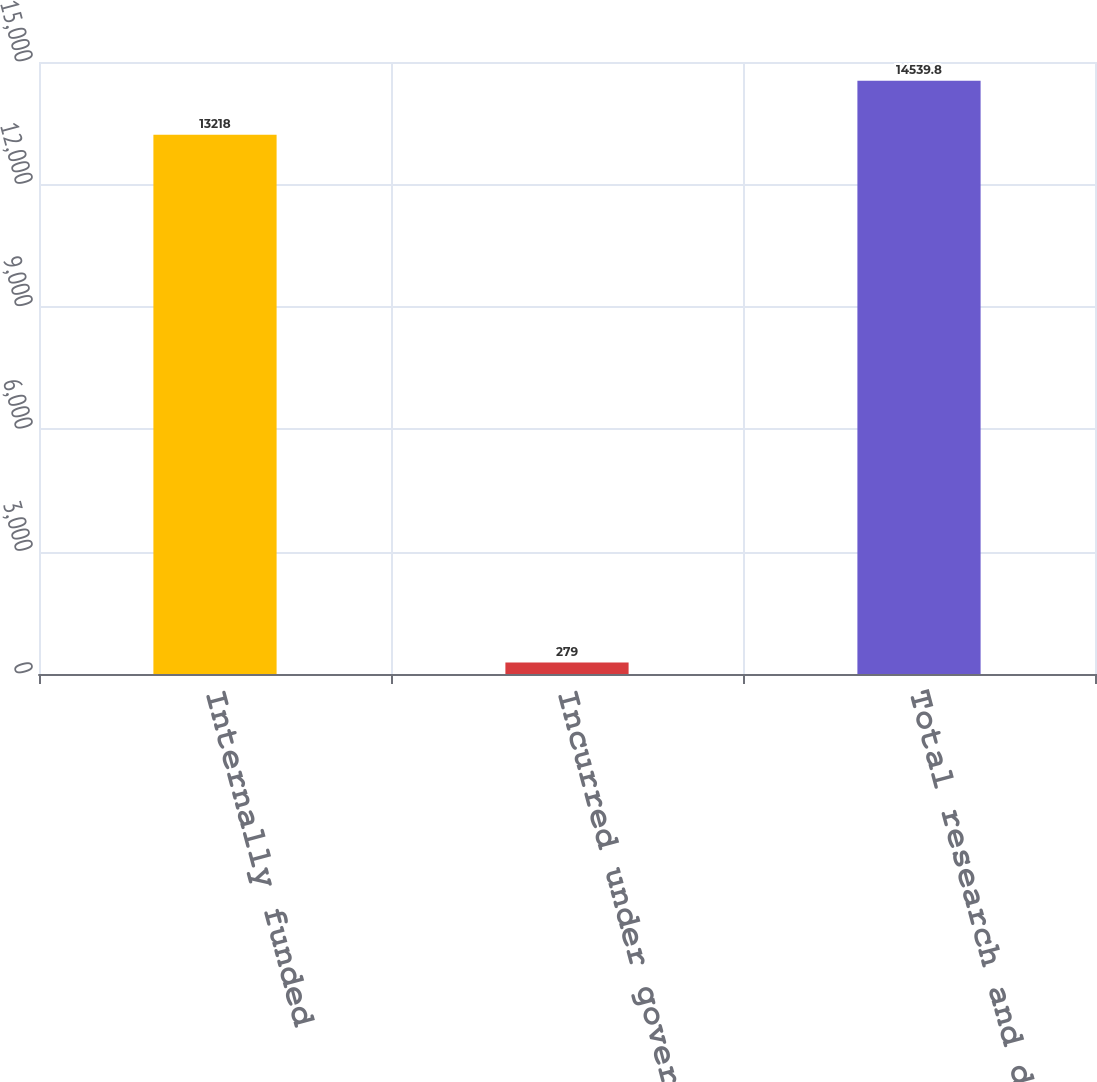Convert chart to OTSL. <chart><loc_0><loc_0><loc_500><loc_500><bar_chart><fcel>Internally funded<fcel>Incurred under government<fcel>Total research and development<nl><fcel>13218<fcel>279<fcel>14539.8<nl></chart> 